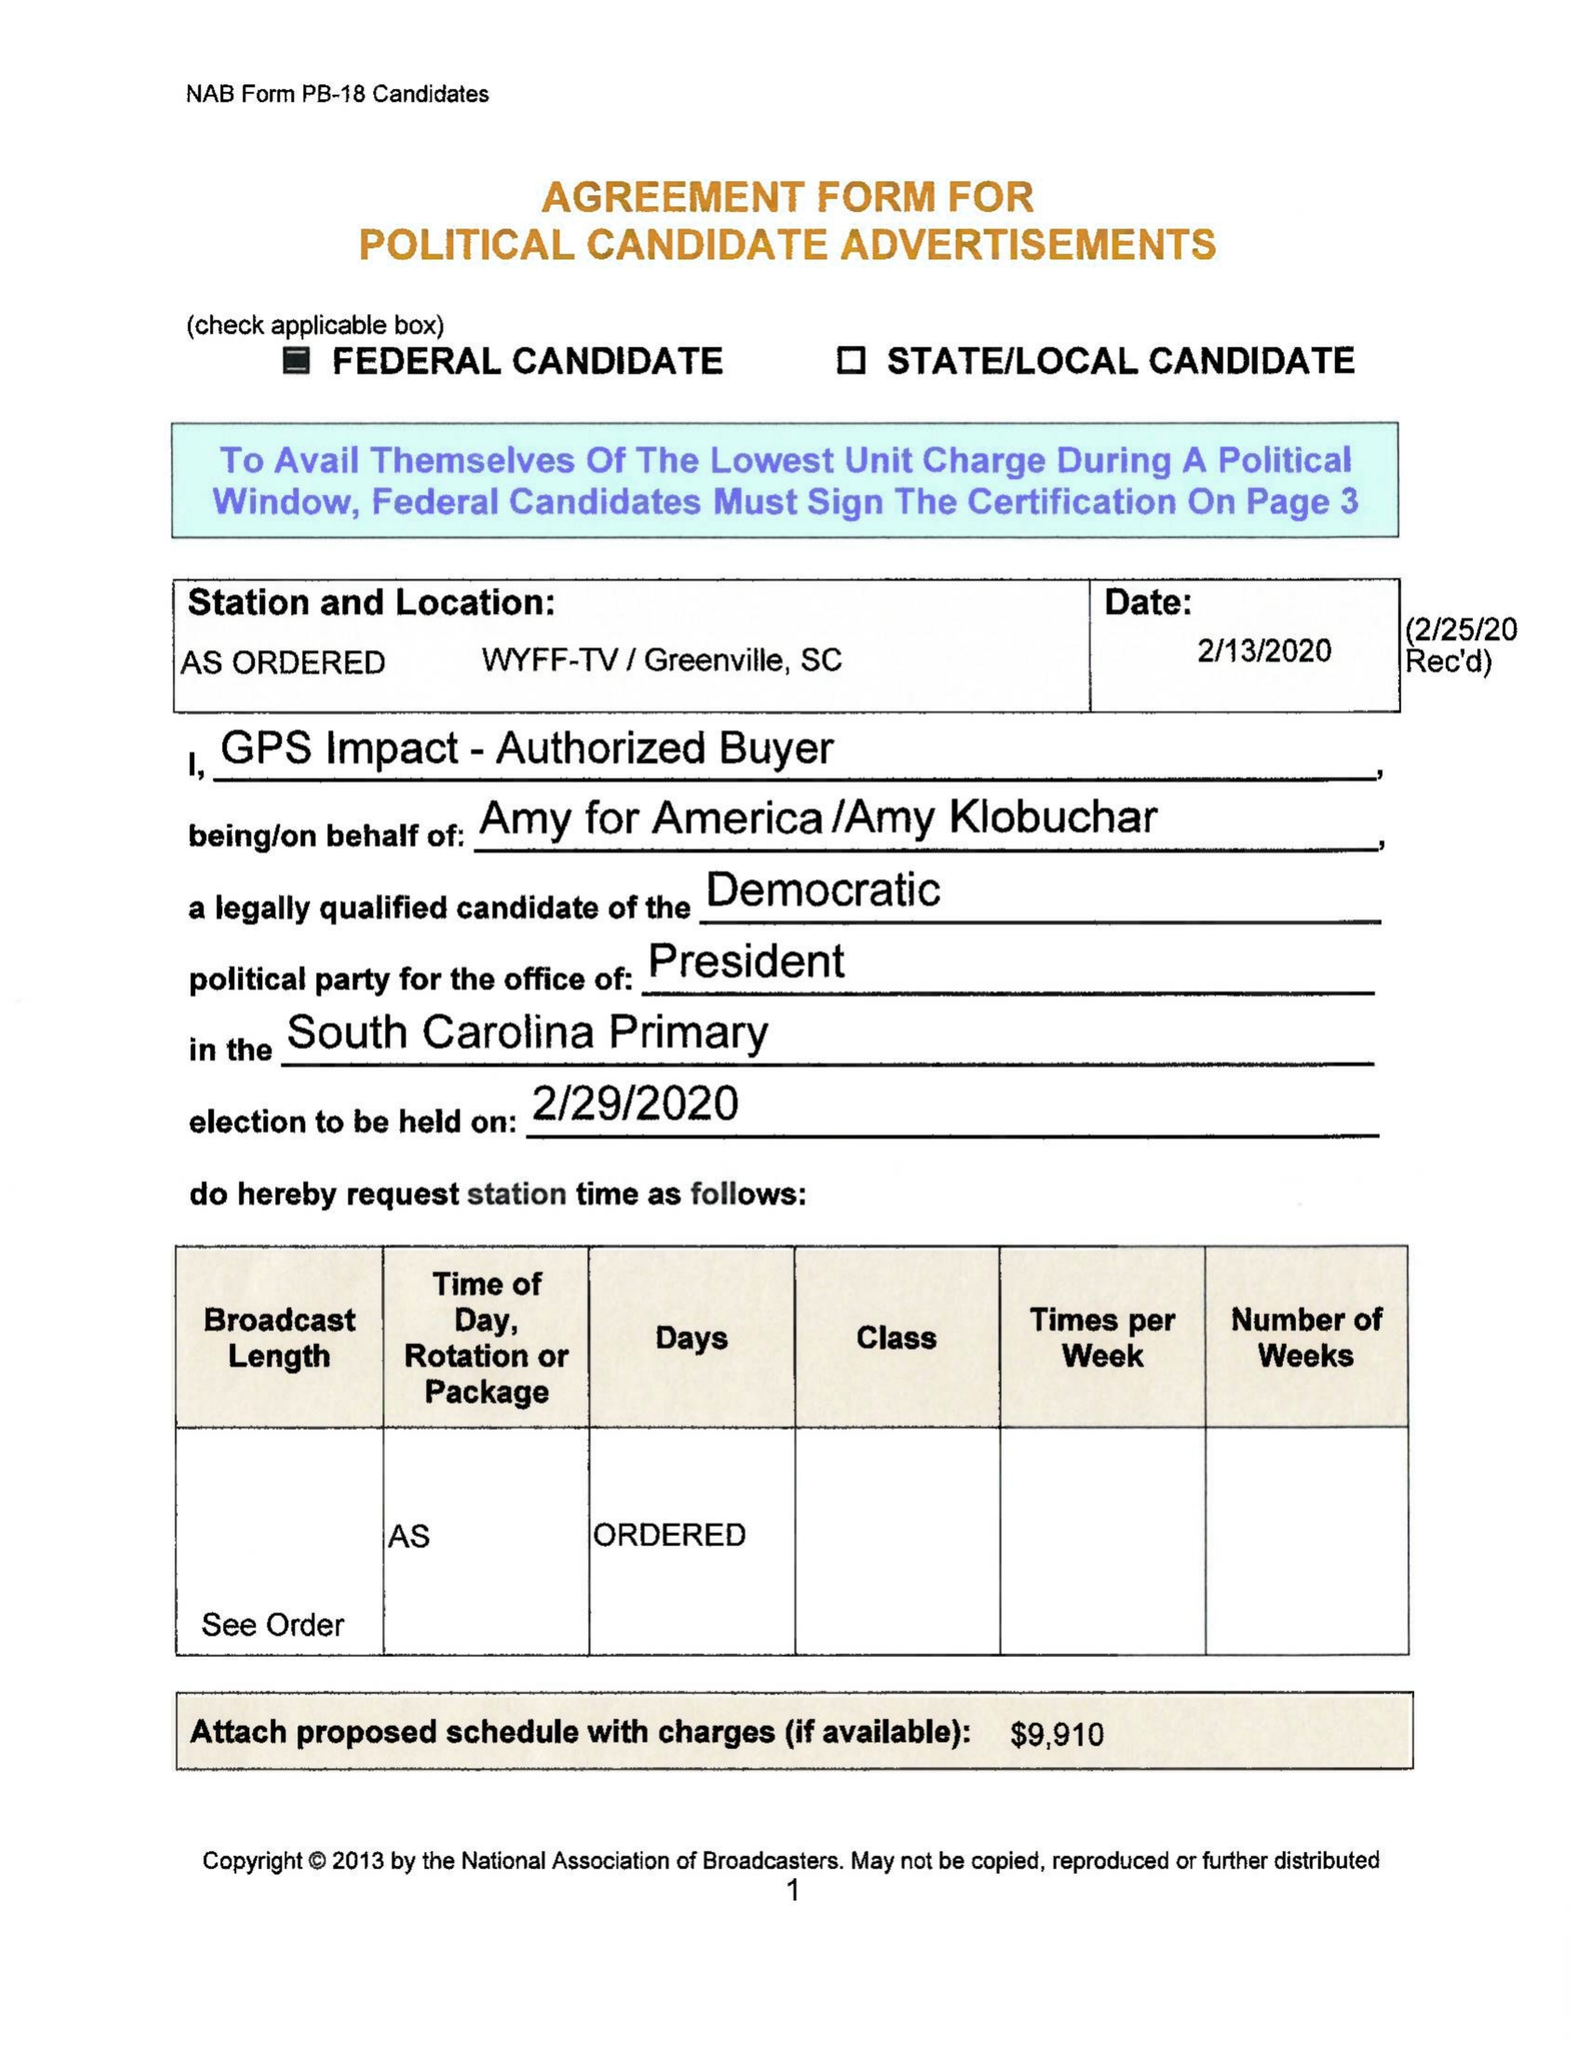What is the value for the contract_num?
Answer the question using a single word or phrase. None 